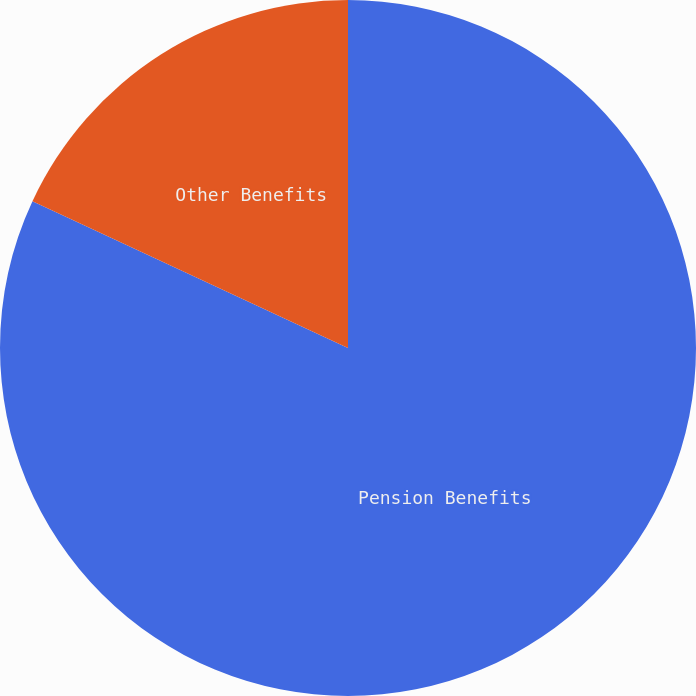Convert chart. <chart><loc_0><loc_0><loc_500><loc_500><pie_chart><fcel>Pension Benefits<fcel>Other Benefits<nl><fcel>81.93%<fcel>18.07%<nl></chart> 